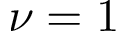Convert formula to latex. <formula><loc_0><loc_0><loc_500><loc_500>\nu = 1</formula> 